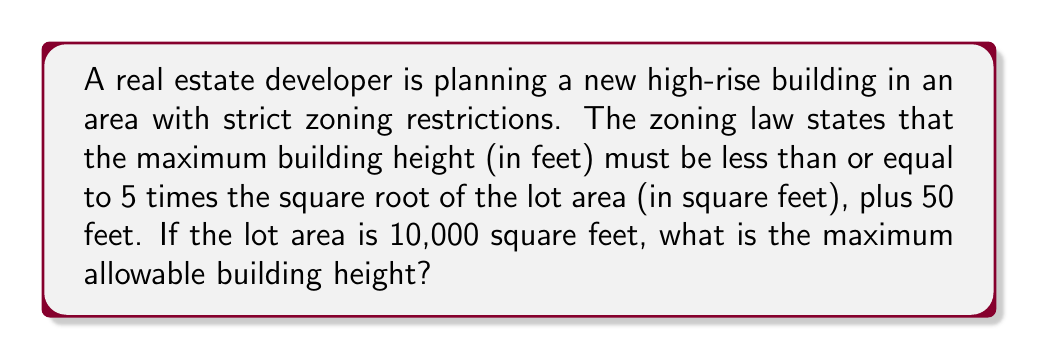Help me with this question. Let's approach this step-by-step:

1) First, let's define our variables:
   $h$ = maximum building height (in feet)
   $A$ = lot area (in square feet)

2) The zoning law can be expressed as an inequality:
   $h \leq 5\sqrt{A} + 50$

3) We're given that the lot area is 10,000 square feet, so:
   $A = 10,000$

4) Substituting this into our inequality:
   $h \leq 5\sqrt{10,000} + 50$

5) Simplify the square root:
   $h \leq 5(100) + 50$

6) Multiply:
   $h \leq 500 + 50$

7) Add:
   $h \leq 550$

8) Therefore, the maximum allowable building height is 550 feet.

As a real estate developer, it's crucial to stay within these zoning restrictions to maintain positive public relations and avoid legal issues.
Answer: 550 feet 